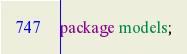<code> <loc_0><loc_0><loc_500><loc_500><_Java_>
package models;</code> 